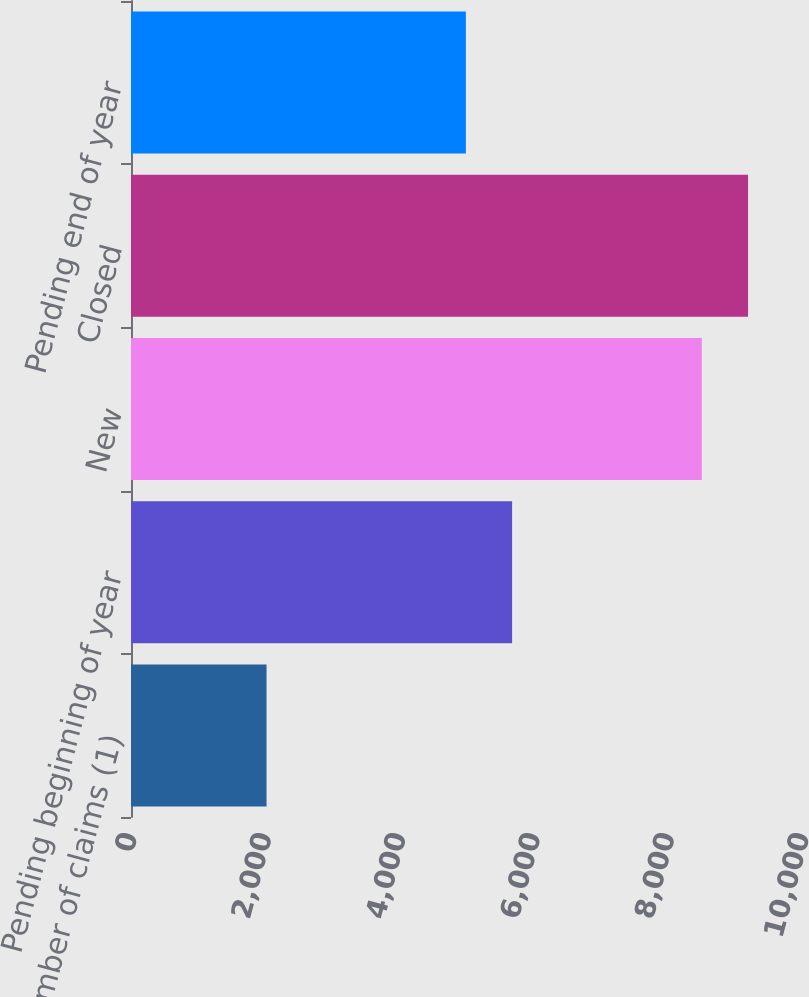Convert chart to OTSL. <chart><loc_0><loc_0><loc_500><loc_500><bar_chart><fcel>Number of claims (1)<fcel>Pending beginning of year<fcel>New<fcel>Closed<fcel>Pending end of year<nl><fcel>2017<fcel>5671.2<fcel>8494<fcel>9182.2<fcel>4983<nl></chart> 